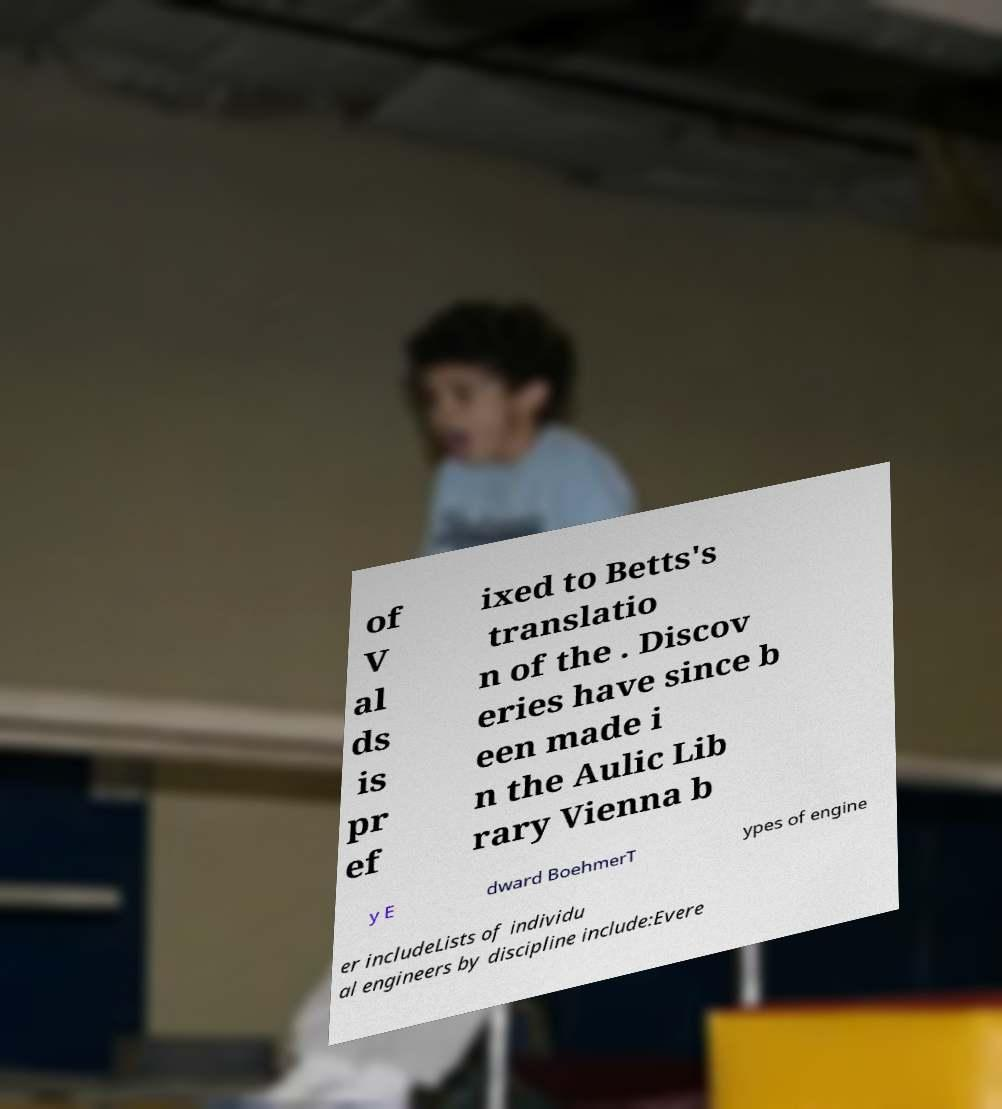There's text embedded in this image that I need extracted. Can you transcribe it verbatim? of V al ds is pr ef ixed to Betts's translatio n of the . Discov eries have since b een made i n the Aulic Lib rary Vienna b y E dward BoehmerT ypes of engine er includeLists of individu al engineers by discipline include:Evere 